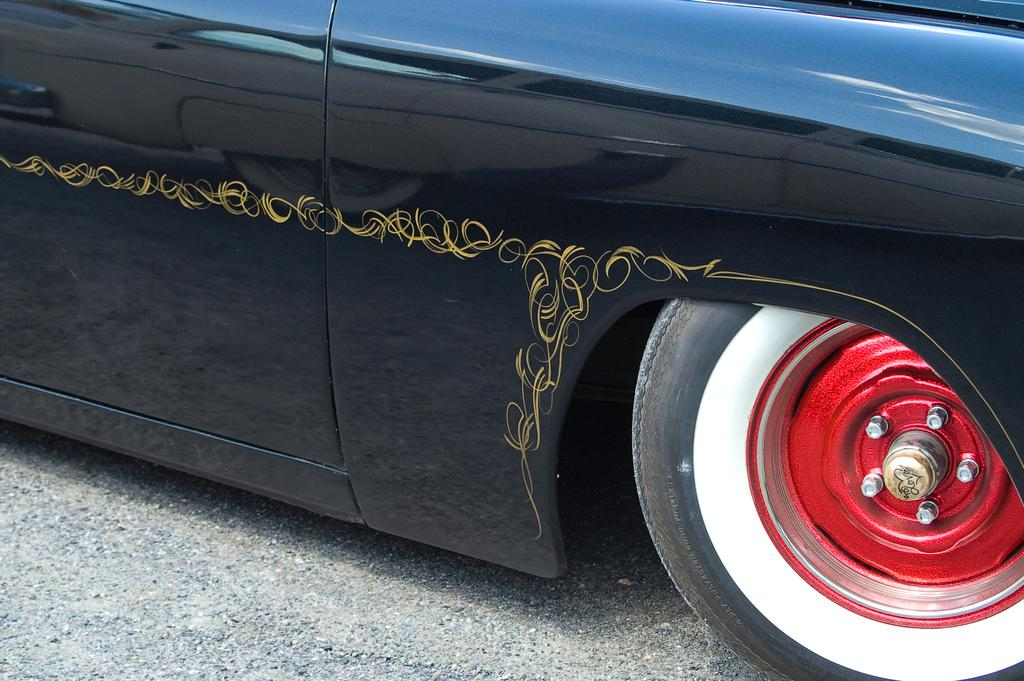What color is the car in the image? The car in the image is black. What can be seen on the road in the image? There is a wheel on the road in the image. What feature of the car is mentioned in the facts? The car has a design. How many feet are visible in the image? There are no feet visible in the image. What type of sink is present in the image? There is no sink present in the image. 